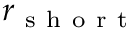<formula> <loc_0><loc_0><loc_500><loc_500>r _ { s h o r t }</formula> 